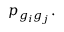<formula> <loc_0><loc_0><loc_500><loc_500>p _ { g _ { i } g _ { j } } .</formula> 